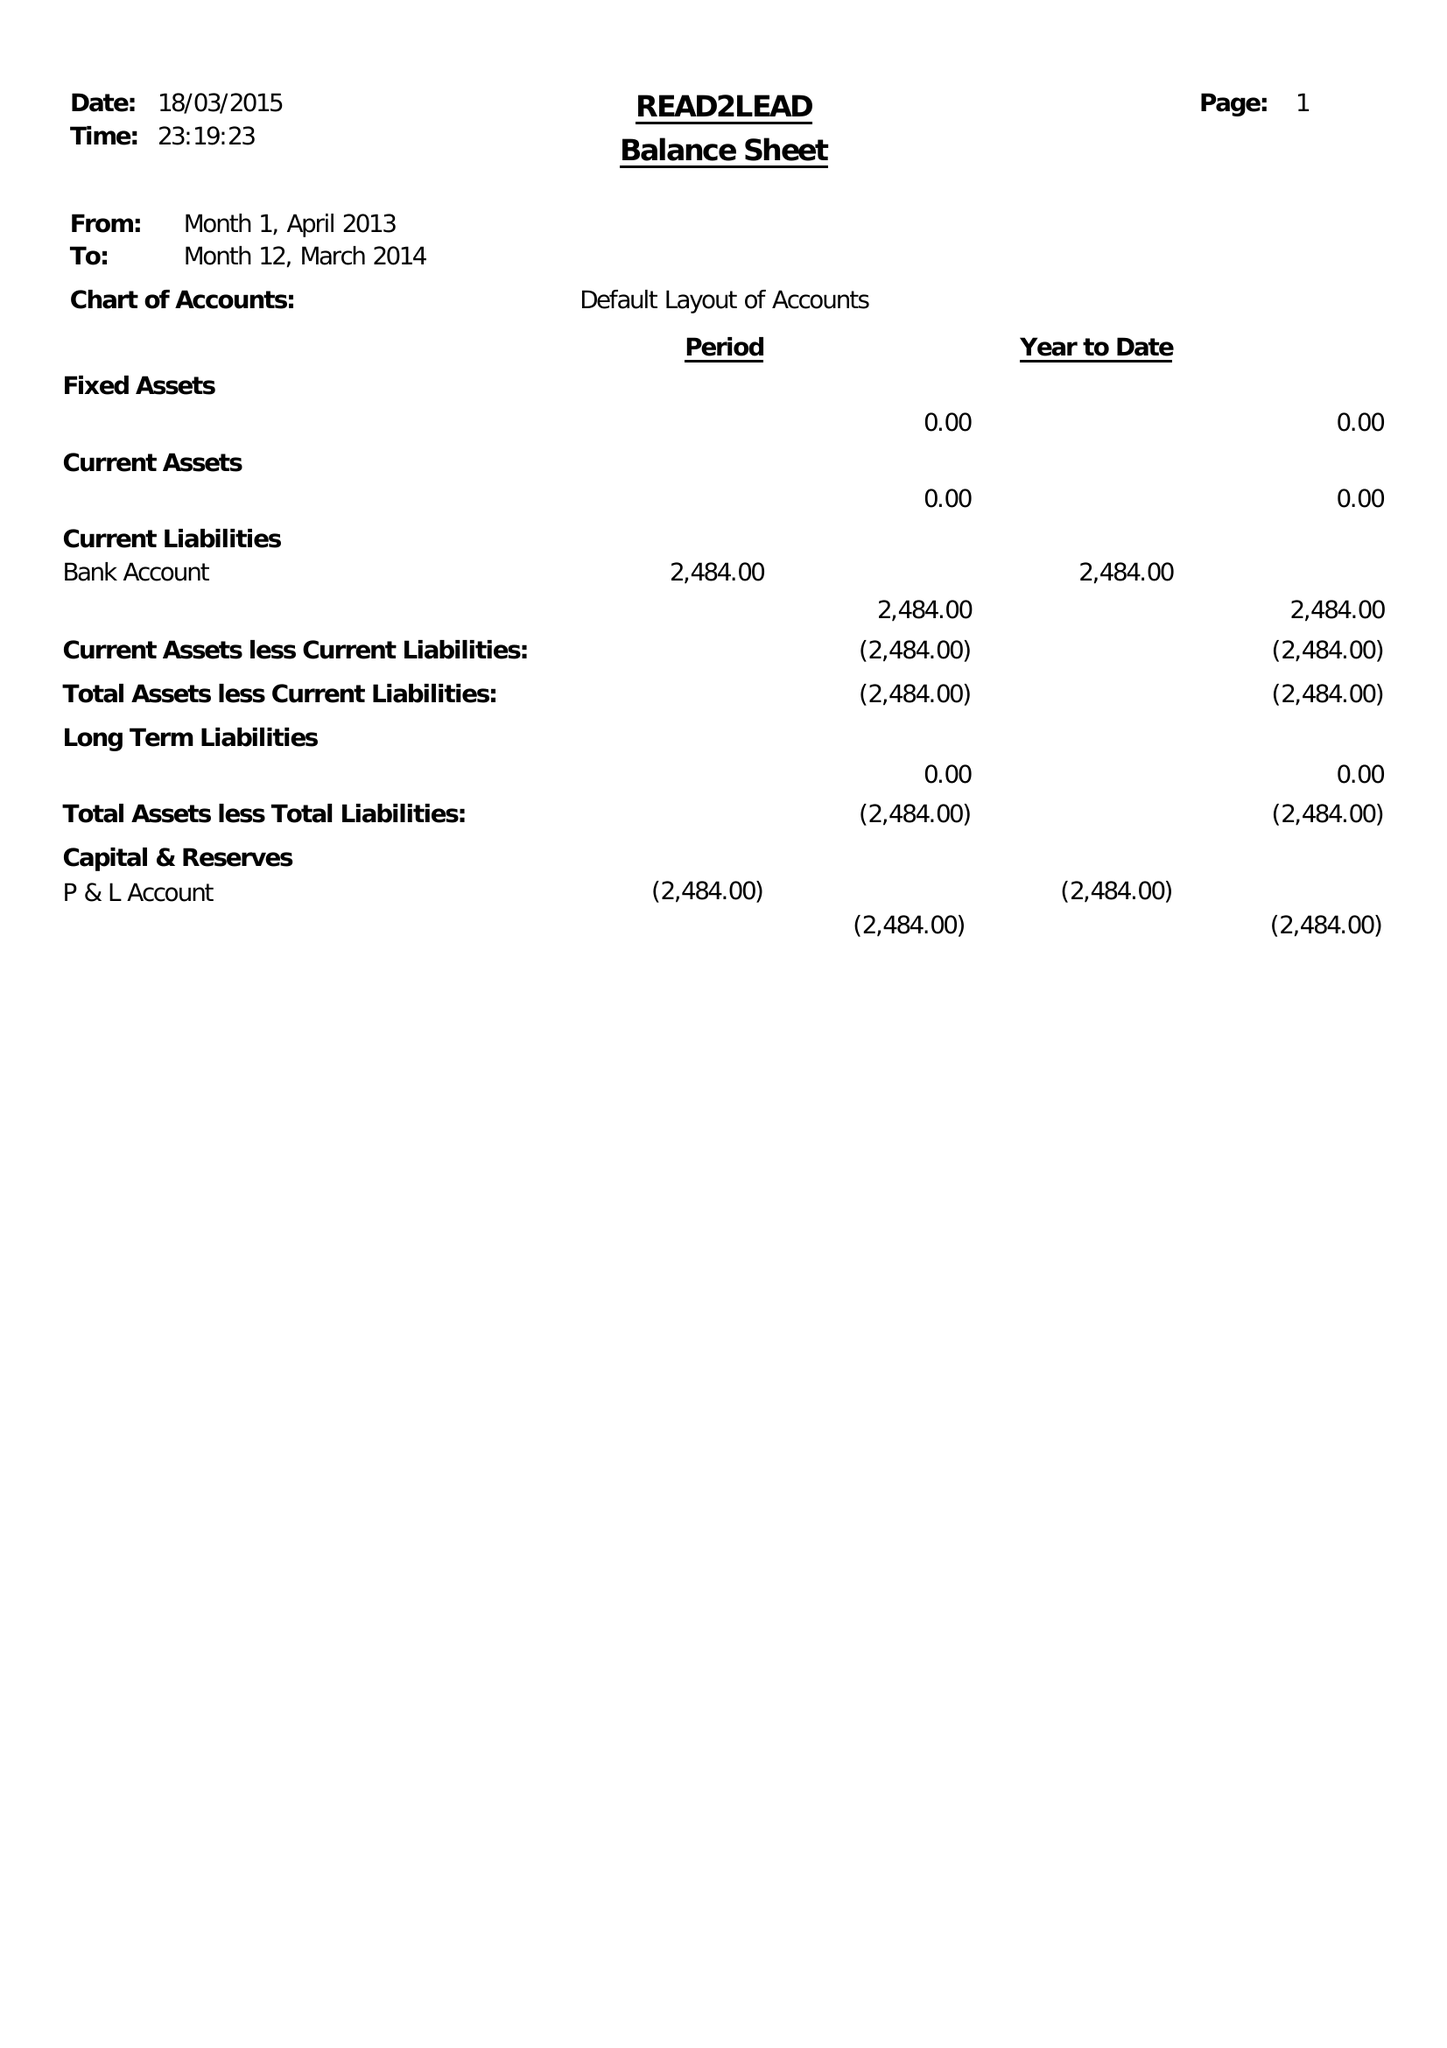What is the value for the report_date?
Answer the question using a single word or phrase. 2014-03-31 